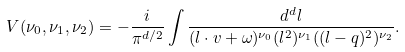Convert formula to latex. <formula><loc_0><loc_0><loc_500><loc_500>V ( \nu _ { 0 } , \nu _ { 1 } , \nu _ { 2 } ) = - \frac { i } { \pi ^ { d / 2 } } \int \frac { d ^ { d } l } { ( l \cdot v + \omega ) ^ { \nu _ { 0 } } ( l ^ { 2 } ) ^ { \nu _ { 1 } } ( ( l - q ) ^ { 2 } ) ^ { \nu _ { 2 } } } .</formula> 